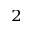Convert formula to latex. <formula><loc_0><loc_0><loc_500><loc_500>_ { 2 }</formula> 